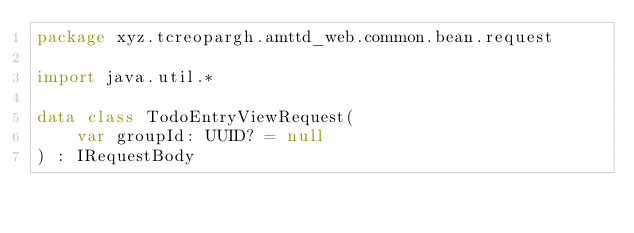Convert code to text. <code><loc_0><loc_0><loc_500><loc_500><_Kotlin_>package xyz.tcreopargh.amttd_web.common.bean.request

import java.util.*

data class TodoEntryViewRequest(
    var groupId: UUID? = null
) : IRequestBody</code> 